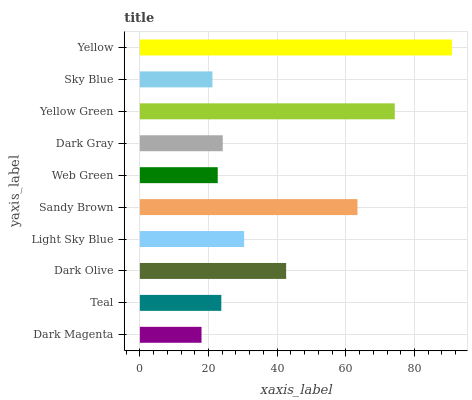Is Dark Magenta the minimum?
Answer yes or no. Yes. Is Yellow the maximum?
Answer yes or no. Yes. Is Teal the minimum?
Answer yes or no. No. Is Teal the maximum?
Answer yes or no. No. Is Teal greater than Dark Magenta?
Answer yes or no. Yes. Is Dark Magenta less than Teal?
Answer yes or no. Yes. Is Dark Magenta greater than Teal?
Answer yes or no. No. Is Teal less than Dark Magenta?
Answer yes or no. No. Is Light Sky Blue the high median?
Answer yes or no. Yes. Is Dark Gray the low median?
Answer yes or no. Yes. Is Yellow Green the high median?
Answer yes or no. No. Is Yellow the low median?
Answer yes or no. No. 